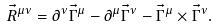Convert formula to latex. <formula><loc_0><loc_0><loc_500><loc_500>\vec { R } ^ { \mu \nu } = \partial ^ { \nu } \vec { \Gamma } ^ { \mu } - \partial ^ { \mu } \vec { \Gamma } ^ { \nu } - \vec { \Gamma } ^ { \mu } \times \vec { \Gamma } ^ { \nu } .</formula> 